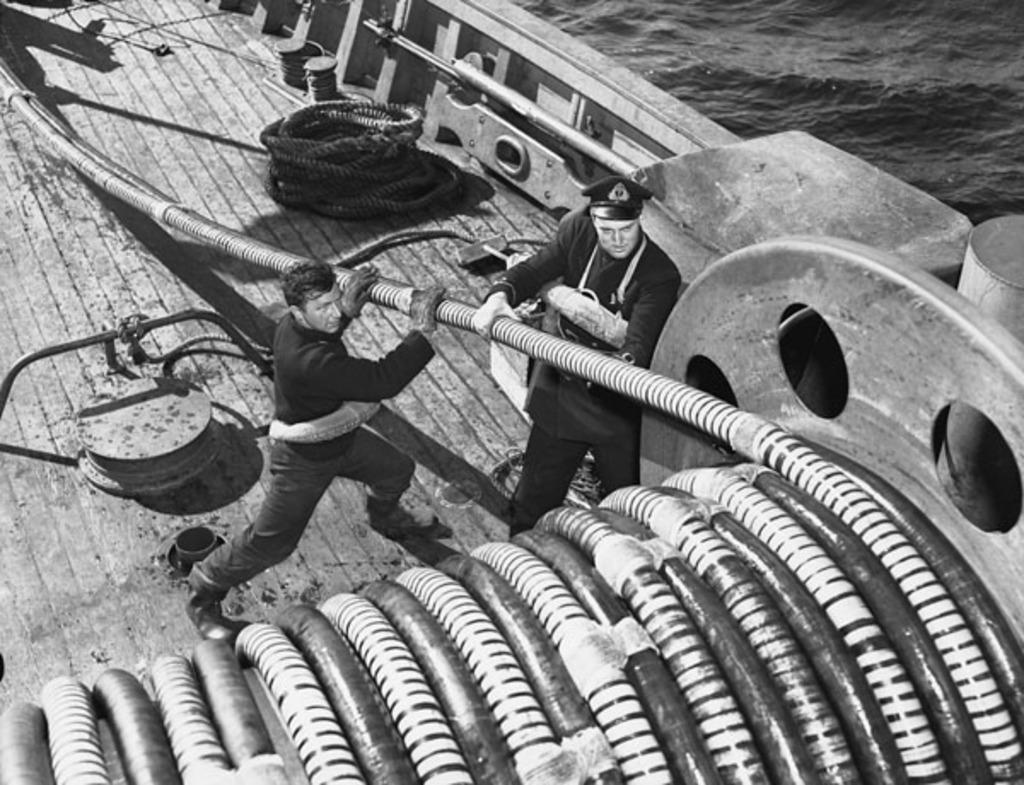Please provide a concise description of this image. In this image I can see two persons standing and holding a pipe which is white and black in color. I can see they are in the boat and I can see the rope, few lids and few other objects in the boat and to the right top of the image I can see the water. 